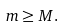Convert formula to latex. <formula><loc_0><loc_0><loc_500><loc_500>m \geq M .</formula> 